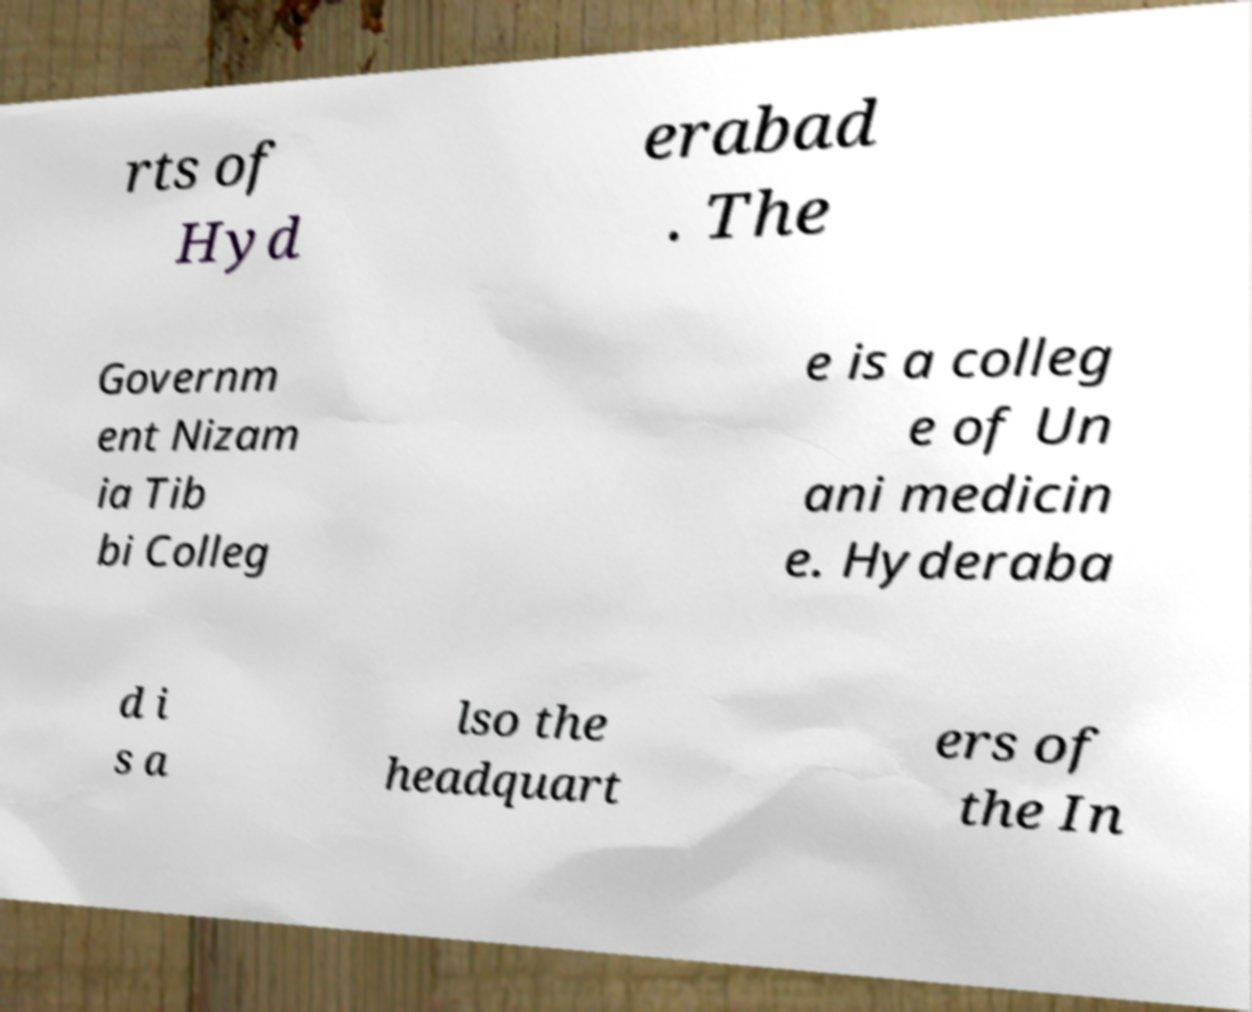Could you extract and type out the text from this image? rts of Hyd erabad . The Governm ent Nizam ia Tib bi Colleg e is a colleg e of Un ani medicin e. Hyderaba d i s a lso the headquart ers of the In 